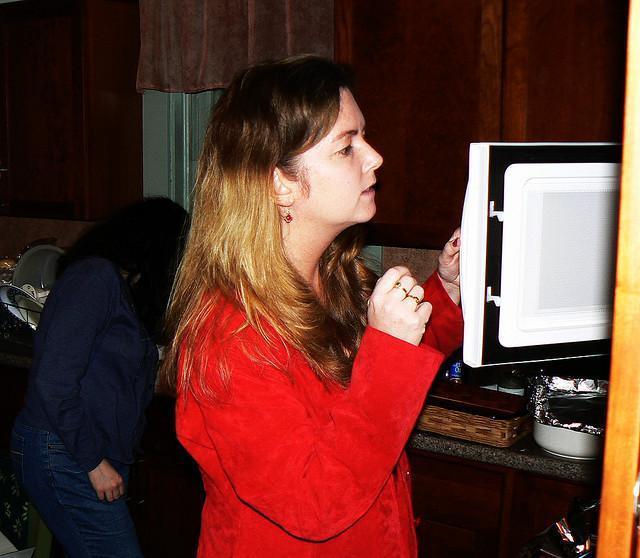How many people can you see?
Give a very brief answer. 2. How many chairs are visible?
Give a very brief answer. 0. 